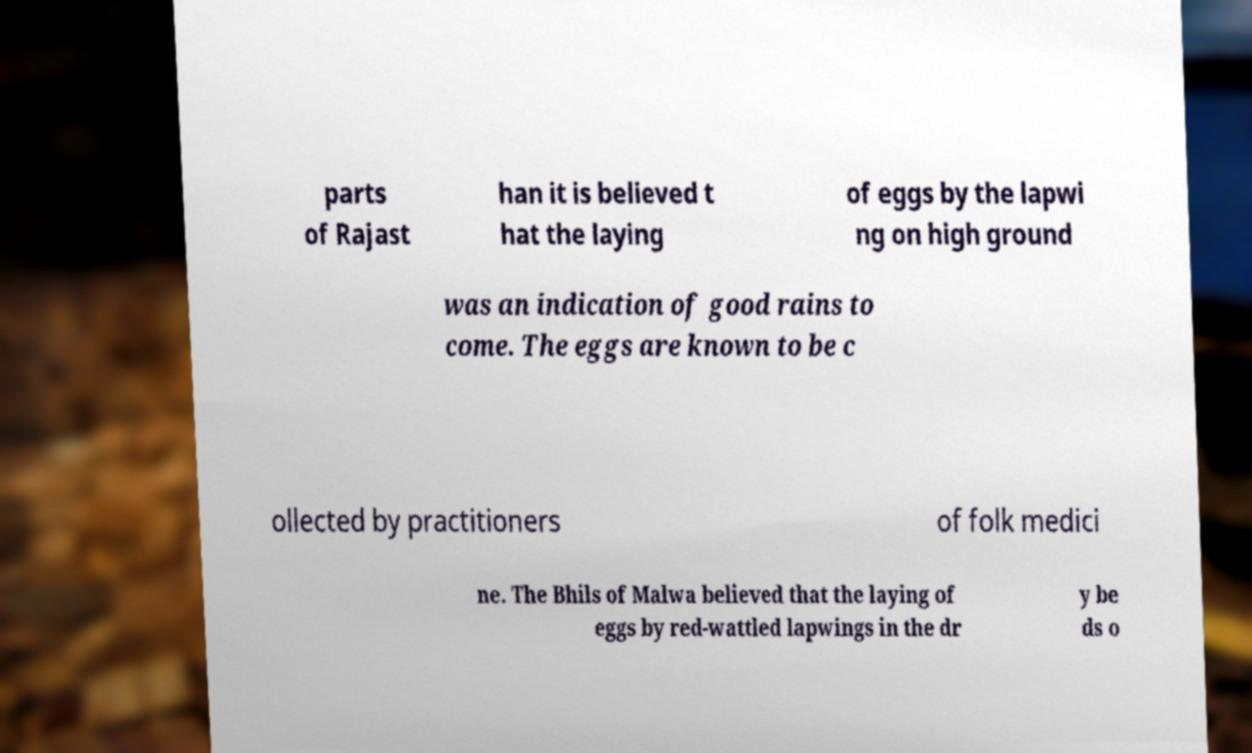For documentation purposes, I need the text within this image transcribed. Could you provide that? parts of Rajast han it is believed t hat the laying of eggs by the lapwi ng on high ground was an indication of good rains to come. The eggs are known to be c ollected by practitioners of folk medici ne. The Bhils of Malwa believed that the laying of eggs by red-wattled lapwings in the dr y be ds o 